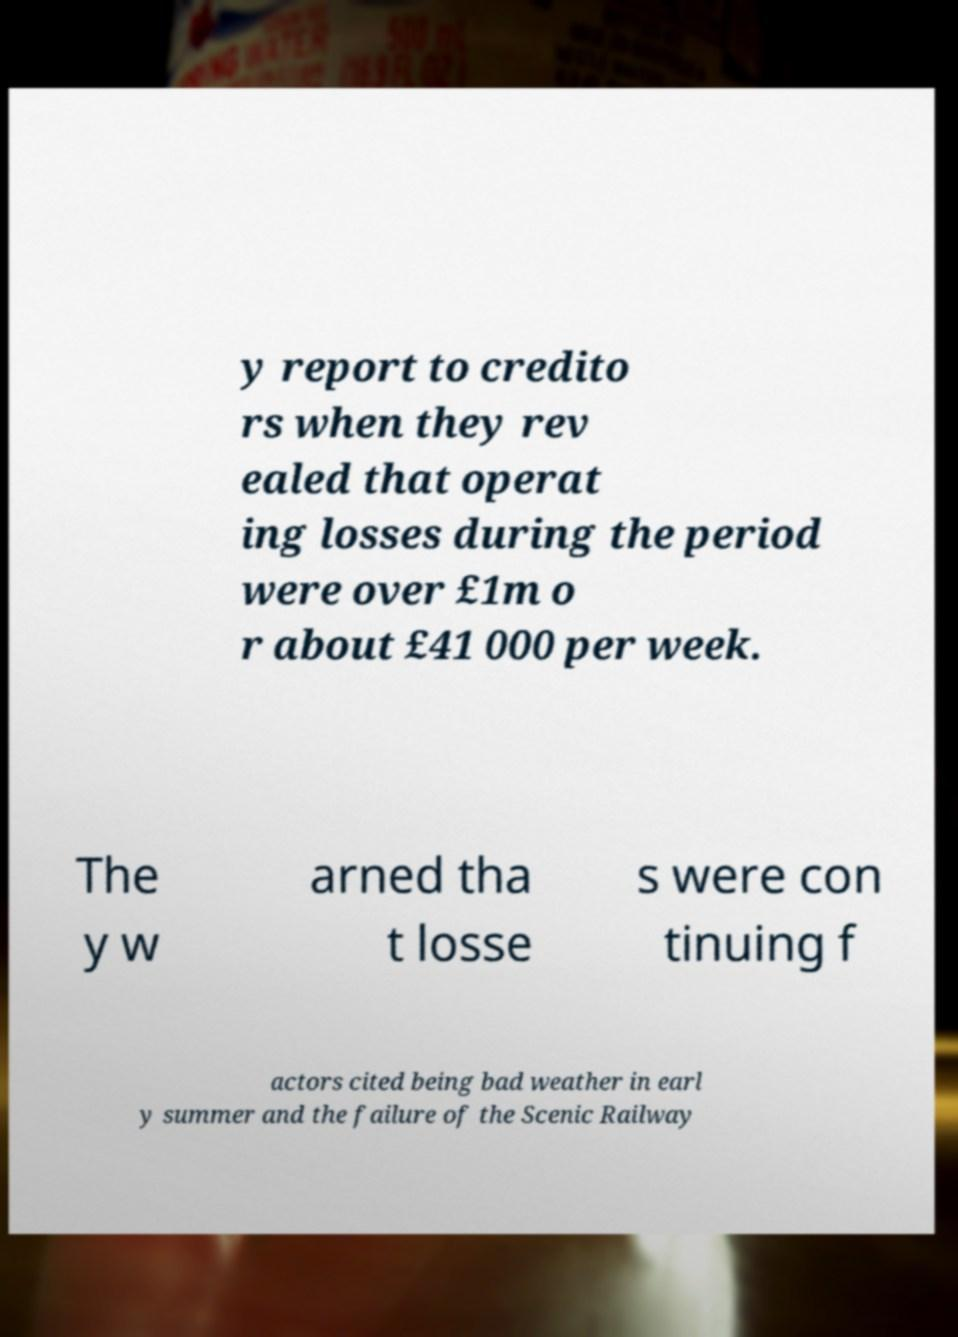I need the written content from this picture converted into text. Can you do that? y report to credito rs when they rev ealed that operat ing losses during the period were over £1m o r about £41 000 per week. The y w arned tha t losse s were con tinuing f actors cited being bad weather in earl y summer and the failure of the Scenic Railway 